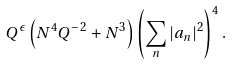<formula> <loc_0><loc_0><loc_500><loc_500>Q ^ { \epsilon } \left ( N ^ { 4 } Q ^ { - 2 } + N ^ { 3 } \right ) \left ( \sum _ { n } | a _ { n } | ^ { 2 } \right ) ^ { 4 } .</formula> 